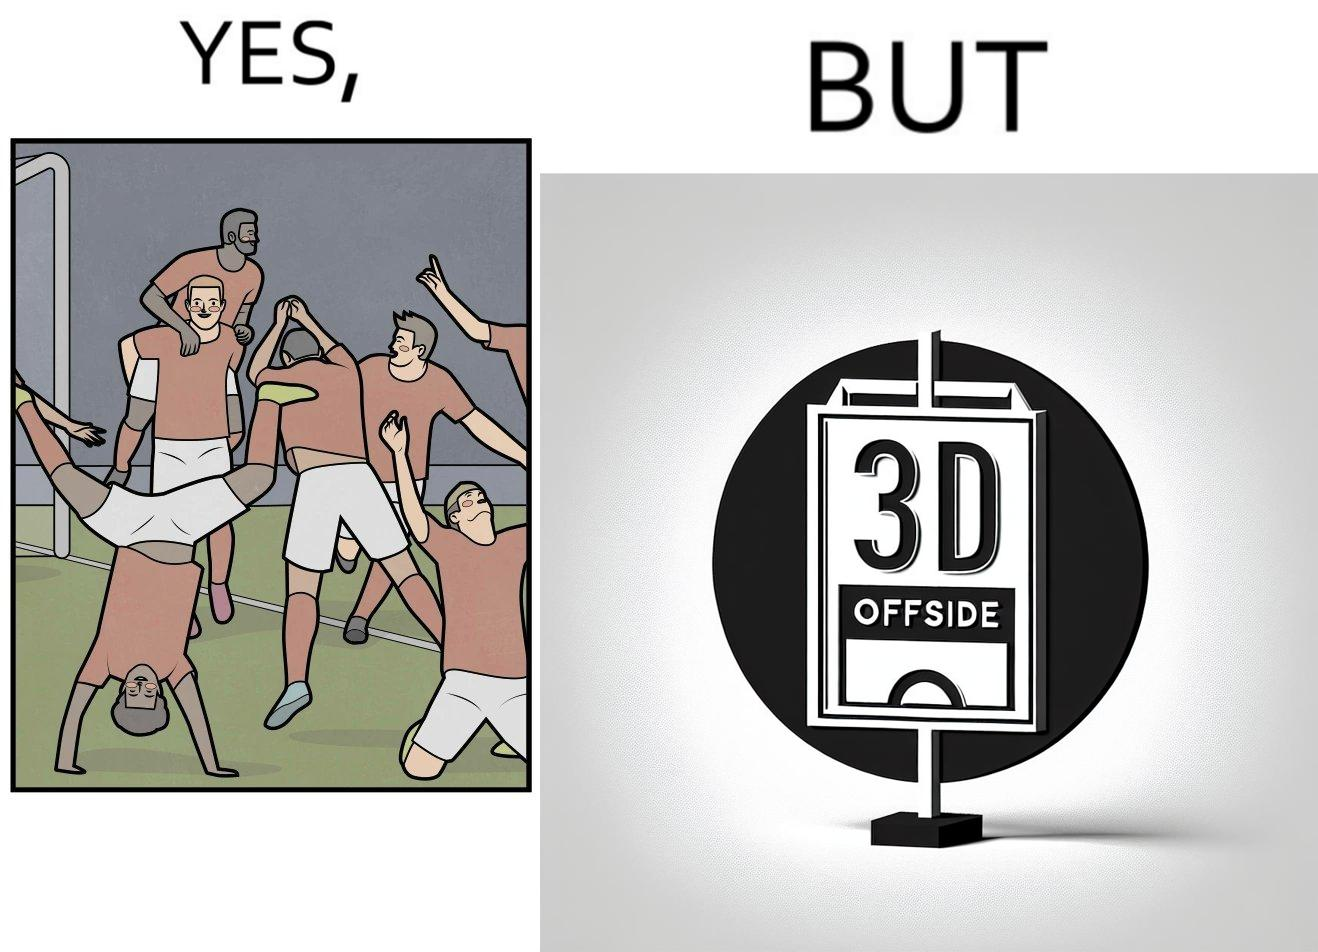Describe the content of this image. The image is ironical, as the team is celebrating as they think that they have scored a goal, but the sign on the screen says that it is an offside, and not a goal. This is a very common scenario in football matches. 